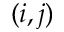<formula> <loc_0><loc_0><loc_500><loc_500>( i , j )</formula> 